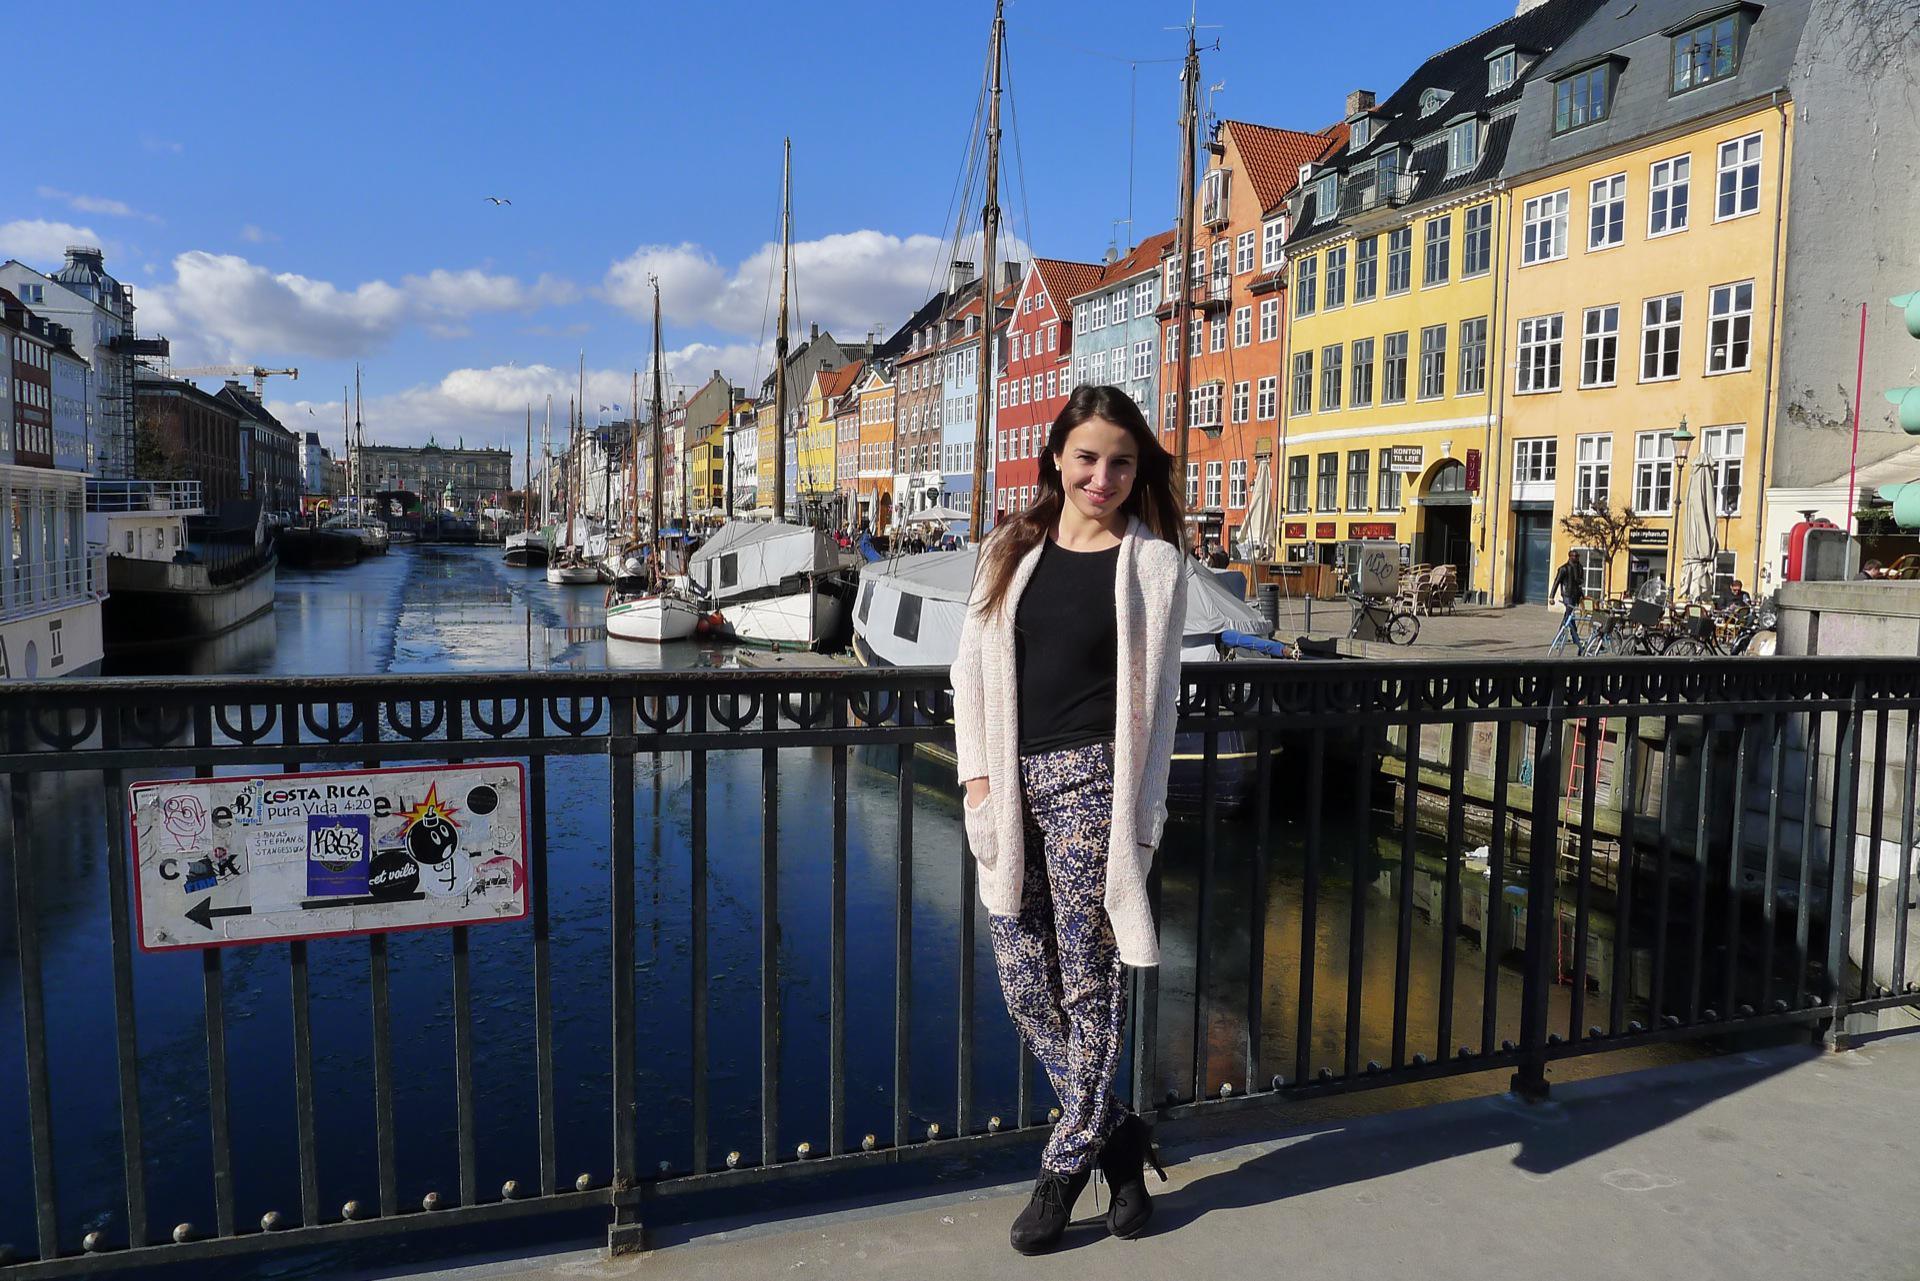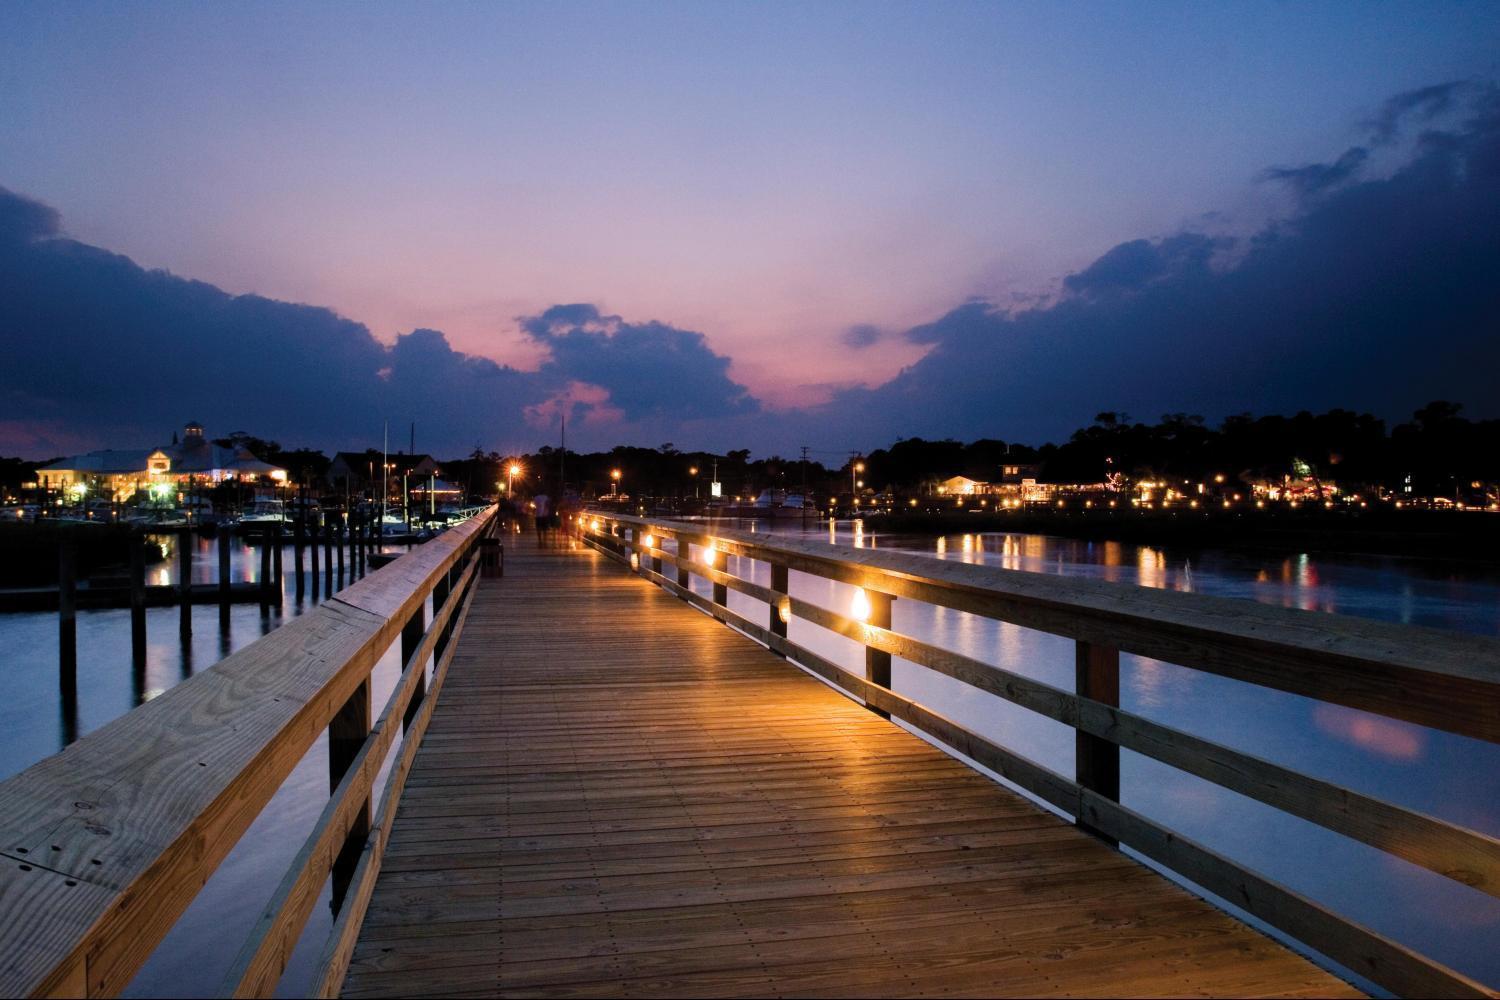The first image is the image on the left, the second image is the image on the right. For the images shown, is this caption "Boats float in the water on a sunny day in the image on the right." true? Answer yes or no. No. 